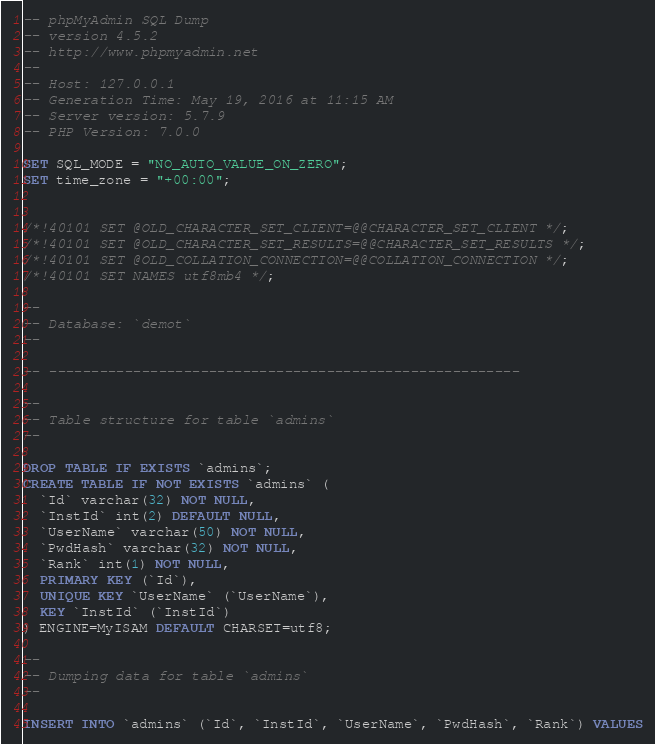Convert code to text. <code><loc_0><loc_0><loc_500><loc_500><_SQL_>-- phpMyAdmin SQL Dump
-- version 4.5.2
-- http://www.phpmyadmin.net
--
-- Host: 127.0.0.1
-- Generation Time: May 19, 2016 at 11:15 AM
-- Server version: 5.7.9
-- PHP Version: 7.0.0

SET SQL_MODE = "NO_AUTO_VALUE_ON_ZERO";
SET time_zone = "+00:00";


/*!40101 SET @OLD_CHARACTER_SET_CLIENT=@@CHARACTER_SET_CLIENT */;
/*!40101 SET @OLD_CHARACTER_SET_RESULTS=@@CHARACTER_SET_RESULTS */;
/*!40101 SET @OLD_COLLATION_CONNECTION=@@COLLATION_CONNECTION */;
/*!40101 SET NAMES utf8mb4 */;

--
-- Database: `demot`
--

-- --------------------------------------------------------

--
-- Table structure for table `admins`
--

DROP TABLE IF EXISTS `admins`;
CREATE TABLE IF NOT EXISTS `admins` (
  `Id` varchar(32) NOT NULL,
  `InstId` int(2) DEFAULT NULL,
  `UserName` varchar(50) NOT NULL,
  `PwdHash` varchar(32) NOT NULL,
  `Rank` int(1) NOT NULL,
  PRIMARY KEY (`Id`),
  UNIQUE KEY `UserName` (`UserName`),
  KEY `InstId` (`InstId`)
) ENGINE=MyISAM DEFAULT CHARSET=utf8;

--
-- Dumping data for table `admins`
--

INSERT INTO `admins` (`Id`, `InstId`, `UserName`, `PwdHash`, `Rank`) VALUES</code> 